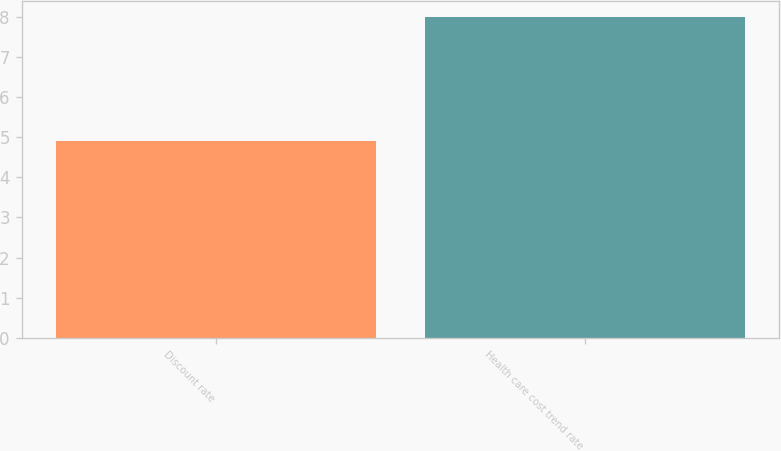<chart> <loc_0><loc_0><loc_500><loc_500><bar_chart><fcel>Discount rate<fcel>Health care cost trend rate<nl><fcel>4.9<fcel>8<nl></chart> 